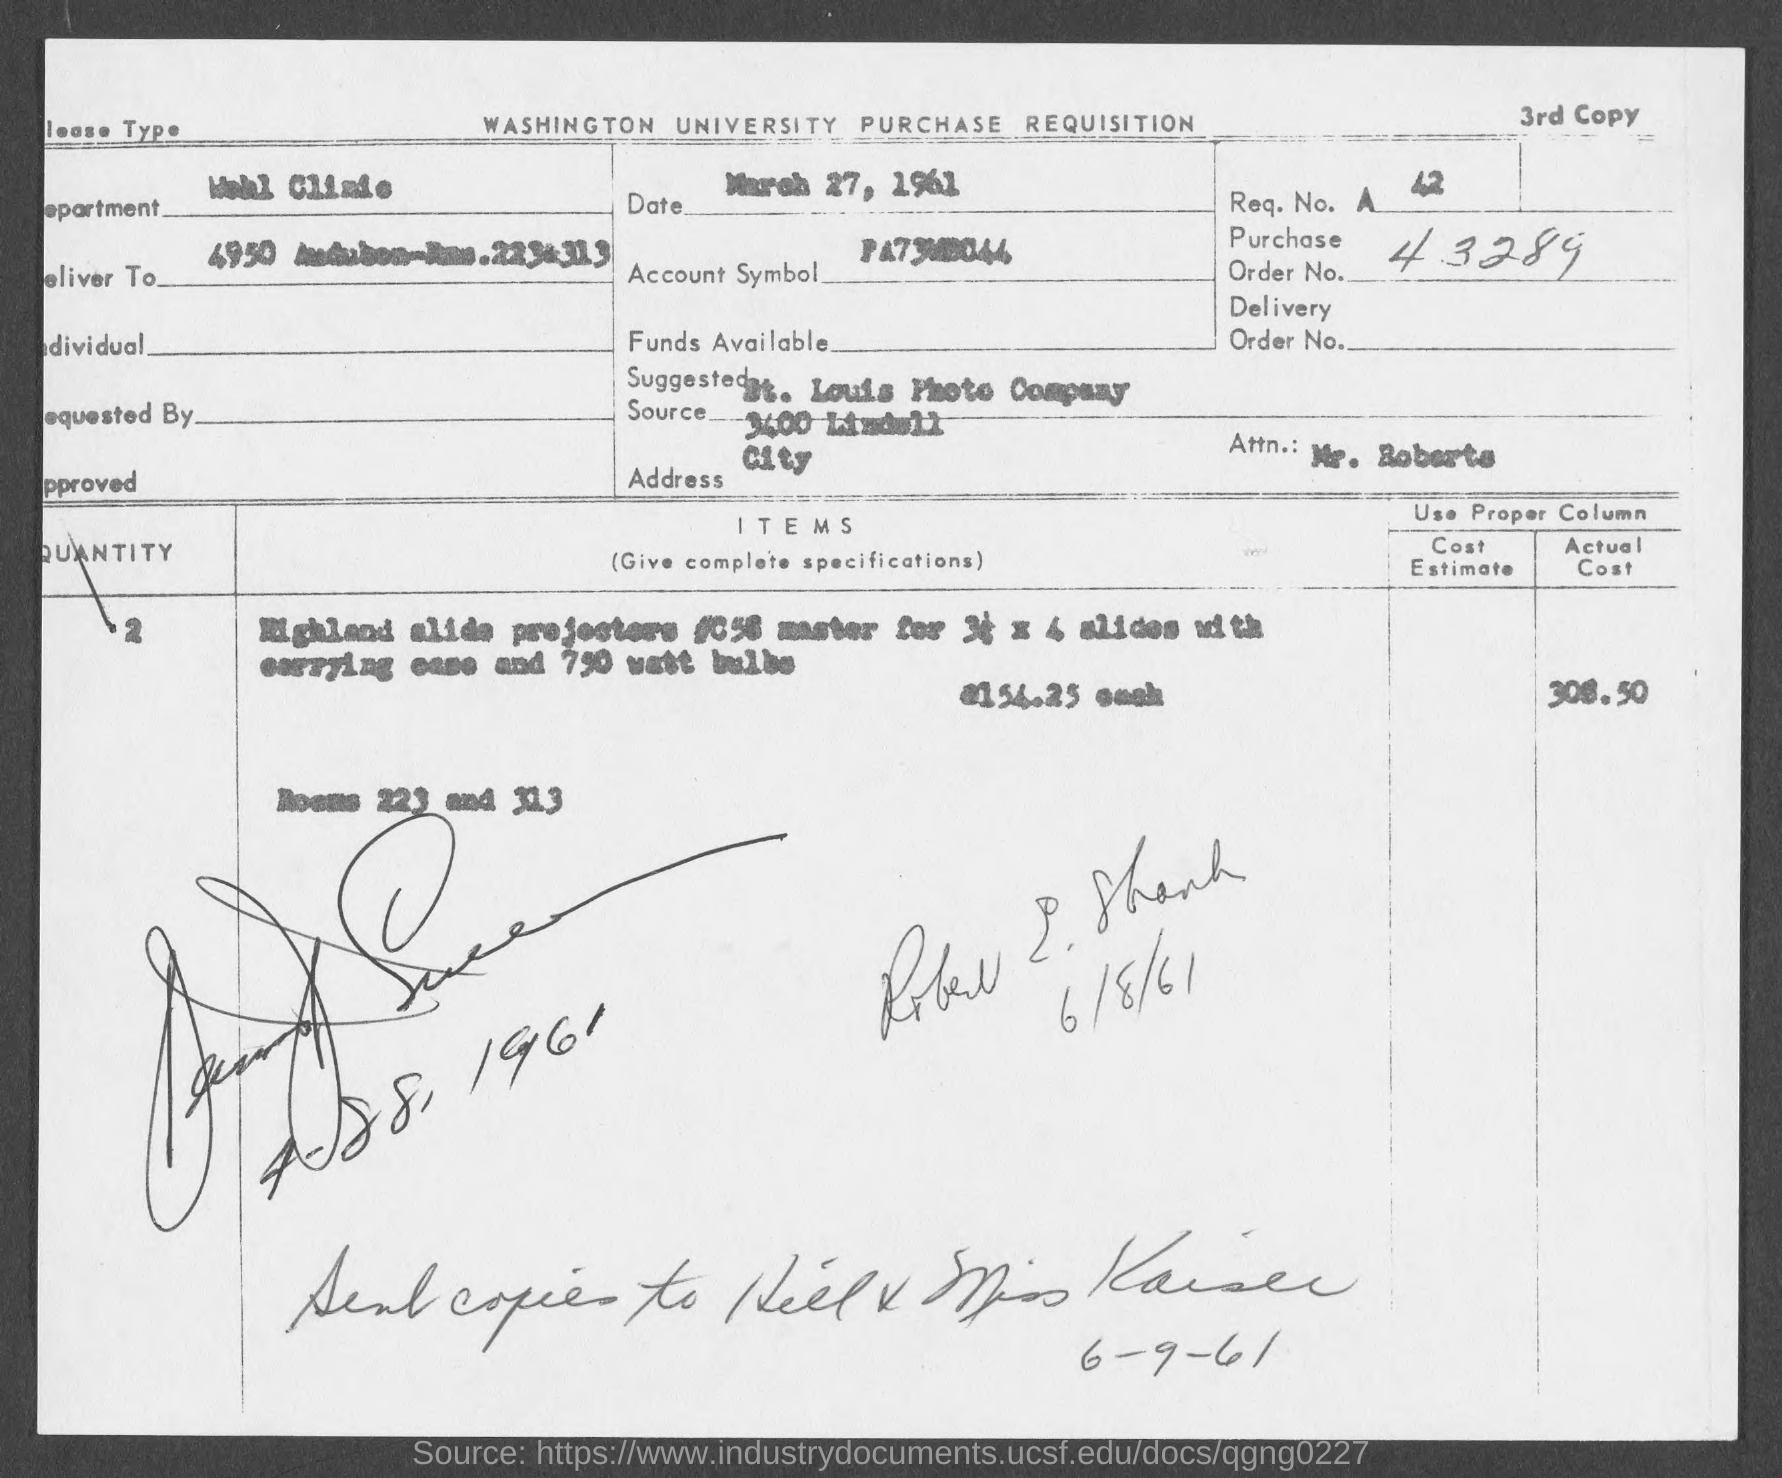Point out several critical features in this image. The department mentioned in the given form is Wohl Clinic. The actual cost of the Highland Alide projectors mentioned in the given form is 308.50 USD. I am unable to answer your question as it is not clear what you are asking. Could you please provide more context or clarify your question? The request number mentioned in the given page is 42. The purchase order number mentioned on the given page is 43289. 